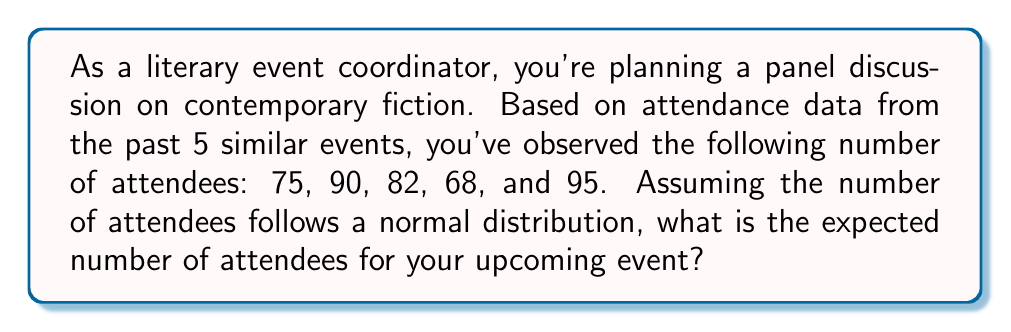What is the answer to this math problem? To determine the expected number of attendees, we need to calculate the mean of the given data points. The mean (μ) represents the expected value of a normally distributed random variable.

Step 1: List the given data points
$x_1 = 75, x_2 = 90, x_3 = 82, x_4 = 68, x_5 = 95$

Step 2: Calculate the sum of all data points
$\sum_{i=1}^{5} x_i = 75 + 90 + 82 + 68 + 95 = 410$

Step 3: Calculate the mean (μ) using the formula:
$$\mu = \frac{\sum_{i=1}^{n} x_i}{n}$$

Where n is the number of data points (in this case, 5).

$$\mu = \frac{410}{5} = 82$$

Therefore, the expected number of attendees for the upcoming event is 82.
Answer: 82 attendees 